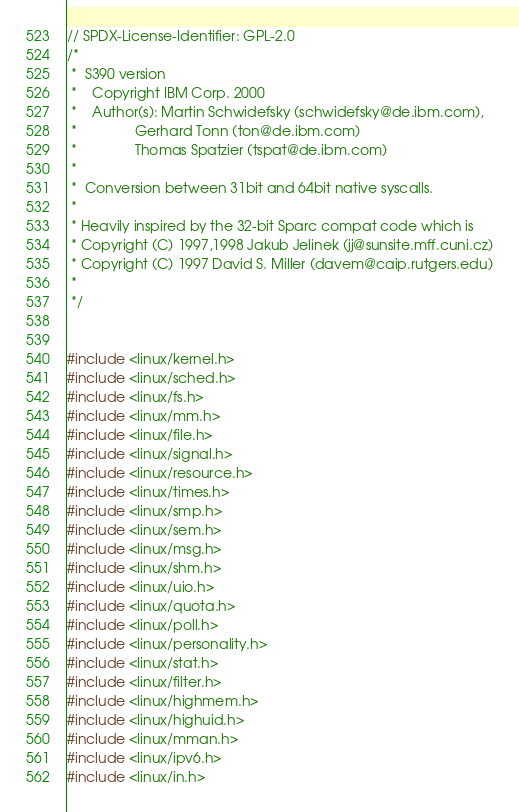Convert code to text. <code><loc_0><loc_0><loc_500><loc_500><_C_>// SPDX-License-Identifier: GPL-2.0
/*
 *  S390 version
 *    Copyright IBM Corp. 2000
 *    Author(s): Martin Schwidefsky (schwidefsky@de.ibm.com),
 *               Gerhard Tonn (ton@de.ibm.com)   
 *               Thomas Spatzier (tspat@de.ibm.com)
 *
 *  Conversion between 31bit and 64bit native syscalls.
 *
 * Heavily inspired by the 32-bit Sparc compat code which is 
 * Copyright (C) 1997,1998 Jakub Jelinek (jj@sunsite.mff.cuni.cz)
 * Copyright (C) 1997 David S. Miller (davem@caip.rutgers.edu)
 *
 */


#include <linux/kernel.h>
#include <linux/sched.h>
#include <linux/fs.h> 
#include <linux/mm.h> 
#include <linux/file.h> 
#include <linux/signal.h>
#include <linux/resource.h>
#include <linux/times.h>
#include <linux/smp.h>
#include <linux/sem.h>
#include <linux/msg.h>
#include <linux/shm.h>
#include <linux/uio.h>
#include <linux/quota.h>
#include <linux/poll.h>
#include <linux/personality.h>
#include <linux/stat.h>
#include <linux/filter.h>
#include <linux/highmem.h>
#include <linux/highuid.h>
#include <linux/mman.h>
#include <linux/ipv6.h>
#include <linux/in.h></code> 